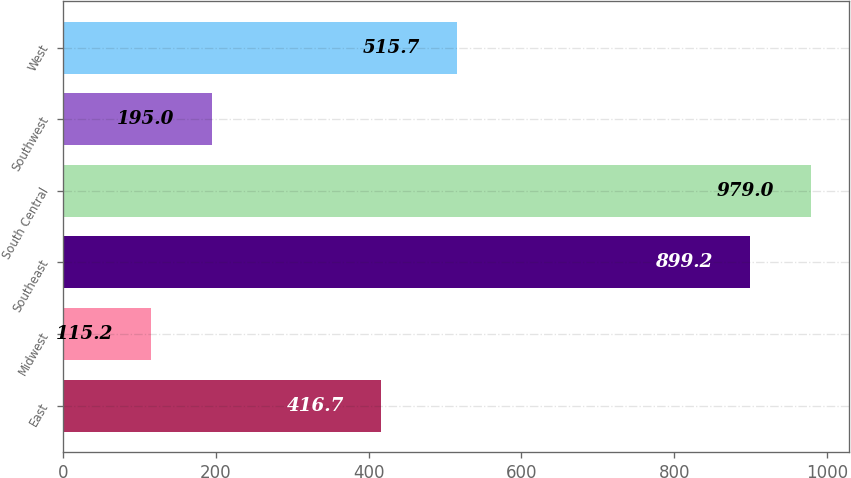<chart> <loc_0><loc_0><loc_500><loc_500><bar_chart><fcel>East<fcel>Midwest<fcel>Southeast<fcel>South Central<fcel>Southwest<fcel>West<nl><fcel>416.7<fcel>115.2<fcel>899.2<fcel>979<fcel>195<fcel>515.7<nl></chart> 